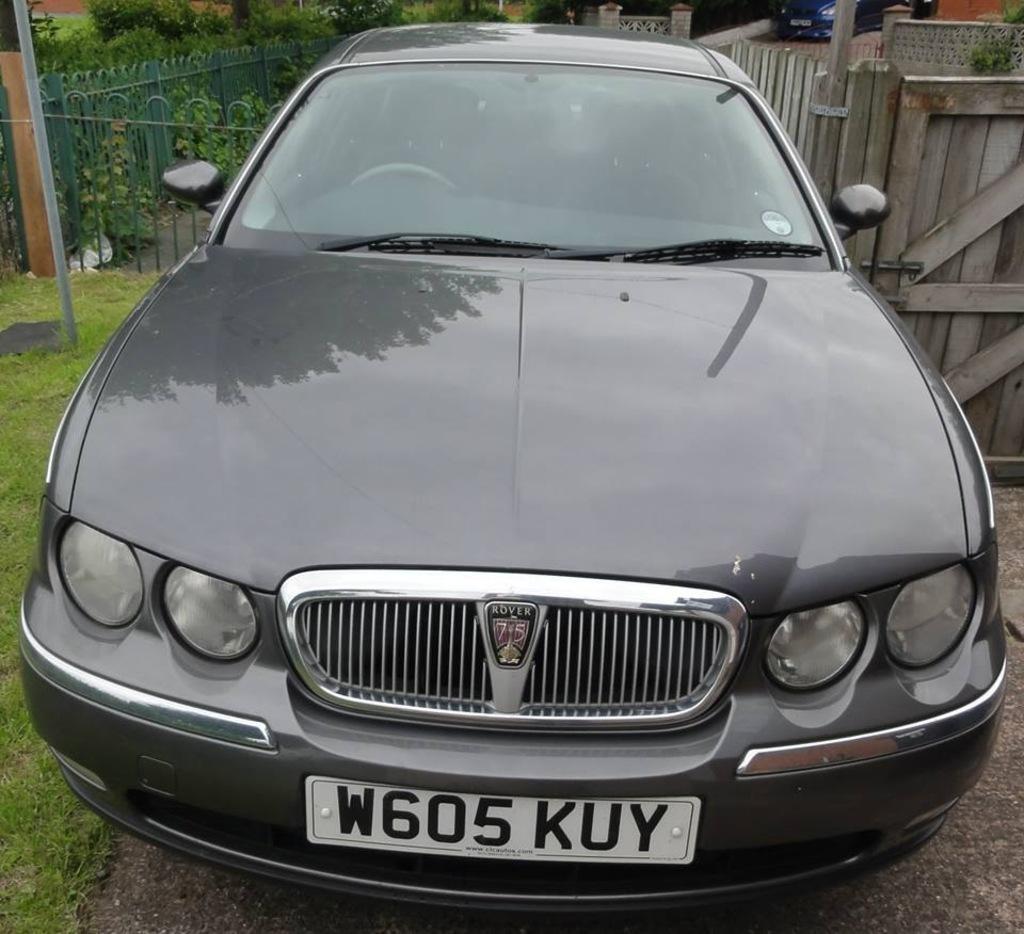Describe this image in one or two sentences. In this image we can see a vehicle on the road. In the background we can see fences, plants, wall, poles, grass on the ground, wall and a vehicle. 